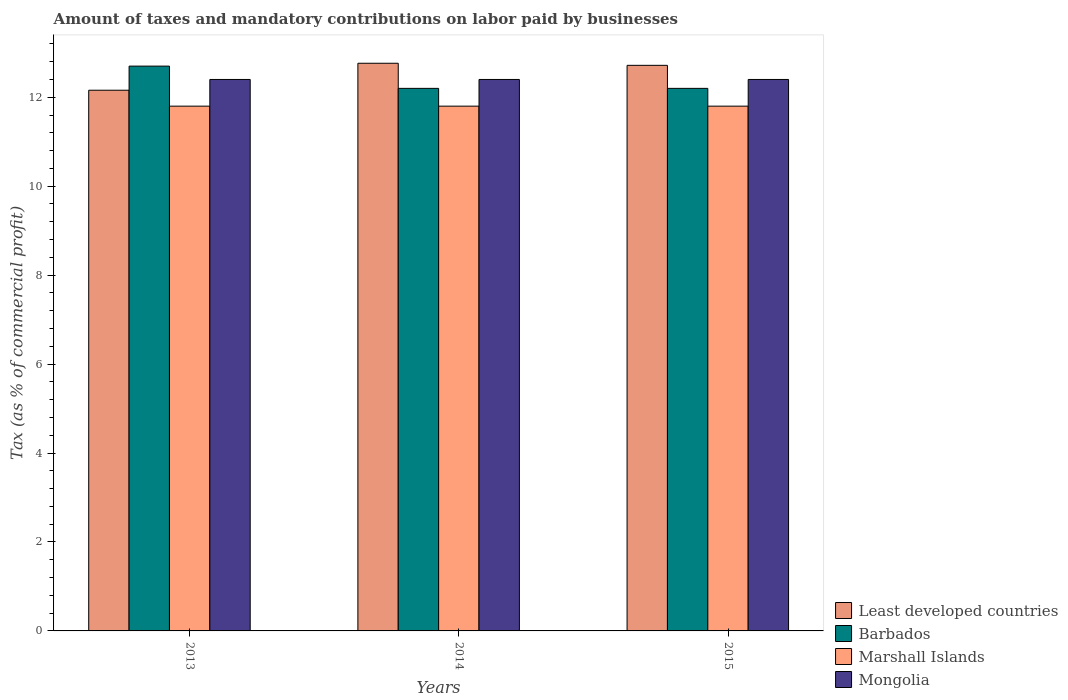Are the number of bars per tick equal to the number of legend labels?
Your response must be concise. Yes. Are the number of bars on each tick of the X-axis equal?
Provide a succinct answer. Yes. In how many cases, is the number of bars for a given year not equal to the number of legend labels?
Offer a terse response. 0. What is the total percentage of taxes paid by businesses in Mongolia in the graph?
Offer a very short reply. 37.2. What is the difference between the percentage of taxes paid by businesses in Marshall Islands in 2015 and the percentage of taxes paid by businesses in Least developed countries in 2013?
Your answer should be compact. -0.36. What is the average percentage of taxes paid by businesses in Least developed countries per year?
Give a very brief answer. 12.55. In the year 2014, what is the difference between the percentage of taxes paid by businesses in Barbados and percentage of taxes paid by businesses in Marshall Islands?
Offer a terse response. 0.4. In how many years, is the percentage of taxes paid by businesses in Barbados greater than 12.4 %?
Your answer should be very brief. 1. What is the ratio of the percentage of taxes paid by businesses in Least developed countries in 2013 to that in 2014?
Offer a very short reply. 0.95. Is the percentage of taxes paid by businesses in Mongolia in 2013 less than that in 2015?
Your answer should be very brief. No. What is the difference between the highest and the second highest percentage of taxes paid by businesses in Barbados?
Offer a terse response. 0.5. What does the 2nd bar from the left in 2014 represents?
Offer a very short reply. Barbados. What does the 4th bar from the right in 2015 represents?
Your answer should be very brief. Least developed countries. Is it the case that in every year, the sum of the percentage of taxes paid by businesses in Barbados and percentage of taxes paid by businesses in Least developed countries is greater than the percentage of taxes paid by businesses in Marshall Islands?
Provide a short and direct response. Yes. How many bars are there?
Provide a short and direct response. 12. What is the difference between two consecutive major ticks on the Y-axis?
Offer a terse response. 2. How many legend labels are there?
Make the answer very short. 4. What is the title of the graph?
Keep it short and to the point. Amount of taxes and mandatory contributions on labor paid by businesses. What is the label or title of the Y-axis?
Your answer should be very brief. Tax (as % of commercial profit). What is the Tax (as % of commercial profit) in Least developed countries in 2013?
Make the answer very short. 12.16. What is the Tax (as % of commercial profit) of Barbados in 2013?
Offer a very short reply. 12.7. What is the Tax (as % of commercial profit) of Marshall Islands in 2013?
Provide a succinct answer. 11.8. What is the Tax (as % of commercial profit) of Mongolia in 2013?
Make the answer very short. 12.4. What is the Tax (as % of commercial profit) in Least developed countries in 2014?
Ensure brevity in your answer.  12.76. What is the Tax (as % of commercial profit) of Barbados in 2014?
Keep it short and to the point. 12.2. What is the Tax (as % of commercial profit) of Marshall Islands in 2014?
Your answer should be very brief. 11.8. What is the Tax (as % of commercial profit) of Least developed countries in 2015?
Your answer should be very brief. 12.72. What is the Tax (as % of commercial profit) of Barbados in 2015?
Your answer should be very brief. 12.2. What is the Tax (as % of commercial profit) in Marshall Islands in 2015?
Provide a succinct answer. 11.8. What is the Tax (as % of commercial profit) in Mongolia in 2015?
Your response must be concise. 12.4. Across all years, what is the maximum Tax (as % of commercial profit) of Least developed countries?
Offer a terse response. 12.76. Across all years, what is the maximum Tax (as % of commercial profit) of Marshall Islands?
Offer a very short reply. 11.8. Across all years, what is the maximum Tax (as % of commercial profit) in Mongolia?
Keep it short and to the point. 12.4. Across all years, what is the minimum Tax (as % of commercial profit) of Least developed countries?
Provide a short and direct response. 12.16. Across all years, what is the minimum Tax (as % of commercial profit) of Mongolia?
Your answer should be very brief. 12.4. What is the total Tax (as % of commercial profit) of Least developed countries in the graph?
Provide a succinct answer. 37.64. What is the total Tax (as % of commercial profit) in Barbados in the graph?
Your answer should be very brief. 37.1. What is the total Tax (as % of commercial profit) in Marshall Islands in the graph?
Keep it short and to the point. 35.4. What is the total Tax (as % of commercial profit) of Mongolia in the graph?
Offer a very short reply. 37.2. What is the difference between the Tax (as % of commercial profit) of Least developed countries in 2013 and that in 2014?
Your response must be concise. -0.61. What is the difference between the Tax (as % of commercial profit) of Barbados in 2013 and that in 2014?
Your answer should be very brief. 0.5. What is the difference between the Tax (as % of commercial profit) in Marshall Islands in 2013 and that in 2014?
Keep it short and to the point. 0. What is the difference between the Tax (as % of commercial profit) in Least developed countries in 2013 and that in 2015?
Offer a very short reply. -0.56. What is the difference between the Tax (as % of commercial profit) of Marshall Islands in 2013 and that in 2015?
Your answer should be compact. 0. What is the difference between the Tax (as % of commercial profit) of Mongolia in 2013 and that in 2015?
Provide a short and direct response. 0. What is the difference between the Tax (as % of commercial profit) in Least developed countries in 2014 and that in 2015?
Your response must be concise. 0.05. What is the difference between the Tax (as % of commercial profit) of Marshall Islands in 2014 and that in 2015?
Provide a short and direct response. 0. What is the difference between the Tax (as % of commercial profit) in Least developed countries in 2013 and the Tax (as % of commercial profit) in Barbados in 2014?
Provide a short and direct response. -0.04. What is the difference between the Tax (as % of commercial profit) in Least developed countries in 2013 and the Tax (as % of commercial profit) in Marshall Islands in 2014?
Offer a very short reply. 0.36. What is the difference between the Tax (as % of commercial profit) of Least developed countries in 2013 and the Tax (as % of commercial profit) of Mongolia in 2014?
Give a very brief answer. -0.24. What is the difference between the Tax (as % of commercial profit) of Marshall Islands in 2013 and the Tax (as % of commercial profit) of Mongolia in 2014?
Make the answer very short. -0.6. What is the difference between the Tax (as % of commercial profit) in Least developed countries in 2013 and the Tax (as % of commercial profit) in Barbados in 2015?
Provide a succinct answer. -0.04. What is the difference between the Tax (as % of commercial profit) of Least developed countries in 2013 and the Tax (as % of commercial profit) of Marshall Islands in 2015?
Make the answer very short. 0.36. What is the difference between the Tax (as % of commercial profit) of Least developed countries in 2013 and the Tax (as % of commercial profit) of Mongolia in 2015?
Keep it short and to the point. -0.24. What is the difference between the Tax (as % of commercial profit) in Barbados in 2013 and the Tax (as % of commercial profit) in Mongolia in 2015?
Your response must be concise. 0.3. What is the difference between the Tax (as % of commercial profit) in Least developed countries in 2014 and the Tax (as % of commercial profit) in Barbados in 2015?
Offer a terse response. 0.56. What is the difference between the Tax (as % of commercial profit) of Least developed countries in 2014 and the Tax (as % of commercial profit) of Marshall Islands in 2015?
Offer a terse response. 0.96. What is the difference between the Tax (as % of commercial profit) in Least developed countries in 2014 and the Tax (as % of commercial profit) in Mongolia in 2015?
Your answer should be very brief. 0.36. What is the difference between the Tax (as % of commercial profit) of Marshall Islands in 2014 and the Tax (as % of commercial profit) of Mongolia in 2015?
Offer a very short reply. -0.6. What is the average Tax (as % of commercial profit) in Least developed countries per year?
Keep it short and to the point. 12.55. What is the average Tax (as % of commercial profit) of Barbados per year?
Keep it short and to the point. 12.37. What is the average Tax (as % of commercial profit) in Marshall Islands per year?
Ensure brevity in your answer.  11.8. What is the average Tax (as % of commercial profit) in Mongolia per year?
Your response must be concise. 12.4. In the year 2013, what is the difference between the Tax (as % of commercial profit) of Least developed countries and Tax (as % of commercial profit) of Barbados?
Keep it short and to the point. -0.54. In the year 2013, what is the difference between the Tax (as % of commercial profit) of Least developed countries and Tax (as % of commercial profit) of Marshall Islands?
Give a very brief answer. 0.36. In the year 2013, what is the difference between the Tax (as % of commercial profit) in Least developed countries and Tax (as % of commercial profit) in Mongolia?
Offer a very short reply. -0.24. In the year 2013, what is the difference between the Tax (as % of commercial profit) in Barbados and Tax (as % of commercial profit) in Marshall Islands?
Ensure brevity in your answer.  0.9. In the year 2013, what is the difference between the Tax (as % of commercial profit) in Marshall Islands and Tax (as % of commercial profit) in Mongolia?
Make the answer very short. -0.6. In the year 2014, what is the difference between the Tax (as % of commercial profit) of Least developed countries and Tax (as % of commercial profit) of Barbados?
Give a very brief answer. 0.56. In the year 2014, what is the difference between the Tax (as % of commercial profit) of Least developed countries and Tax (as % of commercial profit) of Marshall Islands?
Give a very brief answer. 0.96. In the year 2014, what is the difference between the Tax (as % of commercial profit) of Least developed countries and Tax (as % of commercial profit) of Mongolia?
Offer a very short reply. 0.36. In the year 2015, what is the difference between the Tax (as % of commercial profit) in Least developed countries and Tax (as % of commercial profit) in Barbados?
Keep it short and to the point. 0.52. In the year 2015, what is the difference between the Tax (as % of commercial profit) of Least developed countries and Tax (as % of commercial profit) of Marshall Islands?
Make the answer very short. 0.92. In the year 2015, what is the difference between the Tax (as % of commercial profit) in Least developed countries and Tax (as % of commercial profit) in Mongolia?
Your answer should be compact. 0.32. In the year 2015, what is the difference between the Tax (as % of commercial profit) of Barbados and Tax (as % of commercial profit) of Marshall Islands?
Offer a terse response. 0.4. In the year 2015, what is the difference between the Tax (as % of commercial profit) in Marshall Islands and Tax (as % of commercial profit) in Mongolia?
Give a very brief answer. -0.6. What is the ratio of the Tax (as % of commercial profit) of Least developed countries in 2013 to that in 2014?
Provide a succinct answer. 0.95. What is the ratio of the Tax (as % of commercial profit) of Barbados in 2013 to that in 2014?
Your response must be concise. 1.04. What is the ratio of the Tax (as % of commercial profit) of Marshall Islands in 2013 to that in 2014?
Keep it short and to the point. 1. What is the ratio of the Tax (as % of commercial profit) of Least developed countries in 2013 to that in 2015?
Provide a succinct answer. 0.96. What is the ratio of the Tax (as % of commercial profit) in Barbados in 2013 to that in 2015?
Ensure brevity in your answer.  1.04. What is the ratio of the Tax (as % of commercial profit) in Mongolia in 2013 to that in 2015?
Offer a very short reply. 1. What is the ratio of the Tax (as % of commercial profit) in Least developed countries in 2014 to that in 2015?
Offer a very short reply. 1. What is the ratio of the Tax (as % of commercial profit) of Barbados in 2014 to that in 2015?
Make the answer very short. 1. What is the ratio of the Tax (as % of commercial profit) in Marshall Islands in 2014 to that in 2015?
Make the answer very short. 1. What is the difference between the highest and the second highest Tax (as % of commercial profit) in Least developed countries?
Keep it short and to the point. 0.05. What is the difference between the highest and the second highest Tax (as % of commercial profit) of Marshall Islands?
Your answer should be very brief. 0. What is the difference between the highest and the second highest Tax (as % of commercial profit) of Mongolia?
Your answer should be very brief. 0. What is the difference between the highest and the lowest Tax (as % of commercial profit) of Least developed countries?
Your response must be concise. 0.61. What is the difference between the highest and the lowest Tax (as % of commercial profit) of Barbados?
Your answer should be compact. 0.5. What is the difference between the highest and the lowest Tax (as % of commercial profit) of Marshall Islands?
Your answer should be compact. 0. What is the difference between the highest and the lowest Tax (as % of commercial profit) of Mongolia?
Your answer should be compact. 0. 